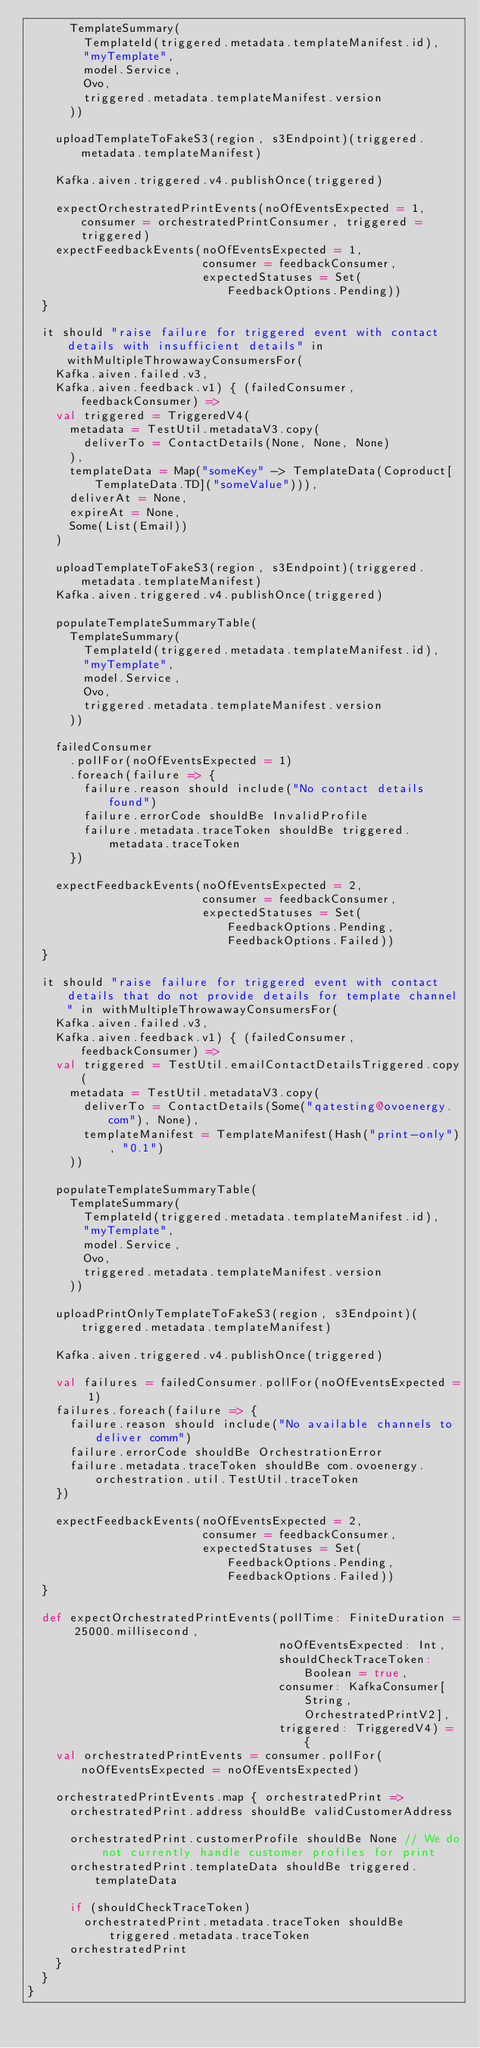<code> <loc_0><loc_0><loc_500><loc_500><_Scala_>      TemplateSummary(
        TemplateId(triggered.metadata.templateManifest.id),
        "myTemplate",
        model.Service,
        Ovo,
        triggered.metadata.templateManifest.version
      ))

    uploadTemplateToFakeS3(region, s3Endpoint)(triggered.metadata.templateManifest)

    Kafka.aiven.triggered.v4.publishOnce(triggered)

    expectOrchestratedPrintEvents(noOfEventsExpected = 1, consumer = orchestratedPrintConsumer, triggered = triggered)
    expectFeedbackEvents(noOfEventsExpected = 1,
                         consumer = feedbackConsumer,
                         expectedStatuses = Set(FeedbackOptions.Pending))
  }

  it should "raise failure for triggered event with contact details with insufficient details" in withMultipleThrowawayConsumersFor(
    Kafka.aiven.failed.v3,
    Kafka.aiven.feedback.v1) { (failedConsumer, feedbackConsumer) =>
    val triggered = TriggeredV4(
      metadata = TestUtil.metadataV3.copy(
        deliverTo = ContactDetails(None, None, None)
      ),
      templateData = Map("someKey" -> TemplateData(Coproduct[TemplateData.TD]("someValue"))),
      deliverAt = None,
      expireAt = None,
      Some(List(Email))
    )

    uploadTemplateToFakeS3(region, s3Endpoint)(triggered.metadata.templateManifest)
    Kafka.aiven.triggered.v4.publishOnce(triggered)

    populateTemplateSummaryTable(
      TemplateSummary(
        TemplateId(triggered.metadata.templateManifest.id),
        "myTemplate",
        model.Service,
        Ovo,
        triggered.metadata.templateManifest.version
      ))

    failedConsumer
      .pollFor(noOfEventsExpected = 1)
      .foreach(failure => {
        failure.reason should include("No contact details found")
        failure.errorCode shouldBe InvalidProfile
        failure.metadata.traceToken shouldBe triggered.metadata.traceToken
      })

    expectFeedbackEvents(noOfEventsExpected = 2,
                         consumer = feedbackConsumer,
                         expectedStatuses = Set(FeedbackOptions.Pending, FeedbackOptions.Failed))
  }

  it should "raise failure for triggered event with contact details that do not provide details for template channel" in withMultipleThrowawayConsumersFor(
    Kafka.aiven.failed.v3,
    Kafka.aiven.feedback.v1) { (failedConsumer, feedbackConsumer) =>
    val triggered = TestUtil.emailContactDetailsTriggered.copy(
      metadata = TestUtil.metadataV3.copy(
        deliverTo = ContactDetails(Some("qatesting@ovoenergy.com"), None),
        templateManifest = TemplateManifest(Hash("print-only"), "0.1")
      ))

    populateTemplateSummaryTable(
      TemplateSummary(
        TemplateId(triggered.metadata.templateManifest.id),
        "myTemplate",
        model.Service,
        Ovo,
        triggered.metadata.templateManifest.version
      ))

    uploadPrintOnlyTemplateToFakeS3(region, s3Endpoint)(triggered.metadata.templateManifest)

    Kafka.aiven.triggered.v4.publishOnce(triggered)

    val failures = failedConsumer.pollFor(noOfEventsExpected = 1)
    failures.foreach(failure => {
      failure.reason should include("No available channels to deliver comm")
      failure.errorCode shouldBe OrchestrationError
      failure.metadata.traceToken shouldBe com.ovoenergy.orchestration.util.TestUtil.traceToken
    })

    expectFeedbackEvents(noOfEventsExpected = 2,
                         consumer = feedbackConsumer,
                         expectedStatuses = Set(FeedbackOptions.Pending, FeedbackOptions.Failed))
  }

  def expectOrchestratedPrintEvents(pollTime: FiniteDuration = 25000.millisecond,
                                    noOfEventsExpected: Int,
                                    shouldCheckTraceToken: Boolean = true,
                                    consumer: KafkaConsumer[String, OrchestratedPrintV2],
                                    triggered: TriggeredV4) = {
    val orchestratedPrintEvents = consumer.pollFor(noOfEventsExpected = noOfEventsExpected)

    orchestratedPrintEvents.map { orchestratedPrint =>
      orchestratedPrint.address shouldBe validCustomerAddress

      orchestratedPrint.customerProfile shouldBe None // We do not currently handle customer profiles for print
      orchestratedPrint.templateData shouldBe triggered.templateData

      if (shouldCheckTraceToken)
        orchestratedPrint.metadata.traceToken shouldBe triggered.metadata.traceToken
      orchestratedPrint
    }
  }
}
</code> 